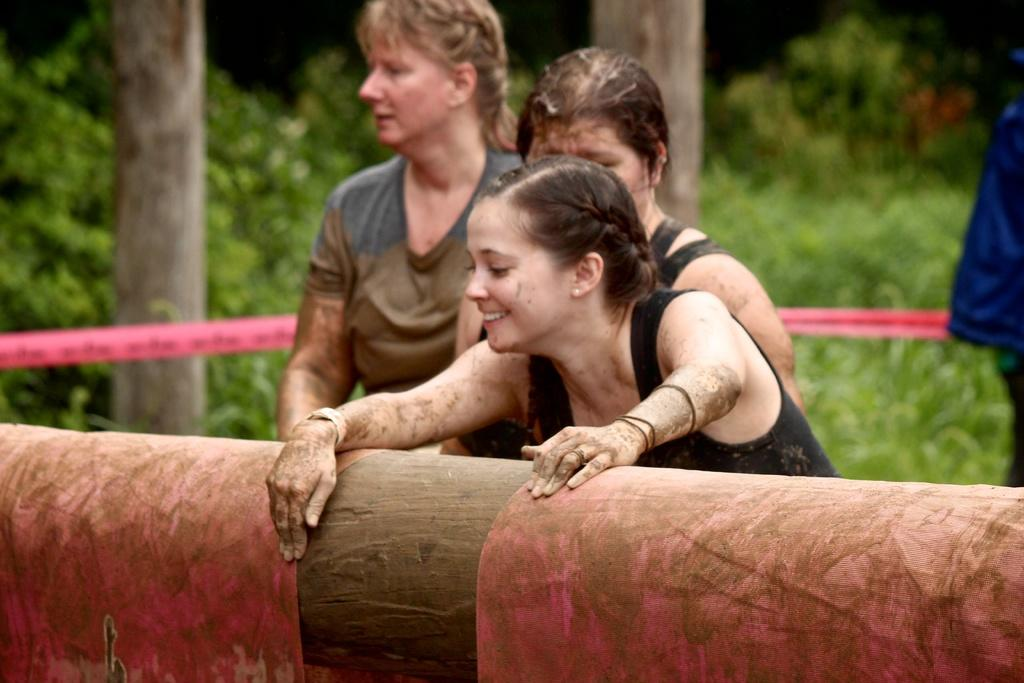How many people are in the image? There are persons in the image, but the exact number is not specified. What objects made of wood can be seen in the image? There are wooden logs in the image. What decorative items are present in the image? There are ribbons in the image. What type of natural environment is visible in the image? There are trees in the image, indicating a natural environment. What type of liquid can be seen flowing through the image? There is no liquid visible in the image. What type of need is being fulfilled by the persons in the image? The facts provided do not give any information about the needs of the persons in the image. 